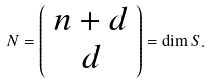Convert formula to latex. <formula><loc_0><loc_0><loc_500><loc_500>N = \left ( \begin{array} { c } n + d \\ d \end{array} \right ) = \dim S .</formula> 